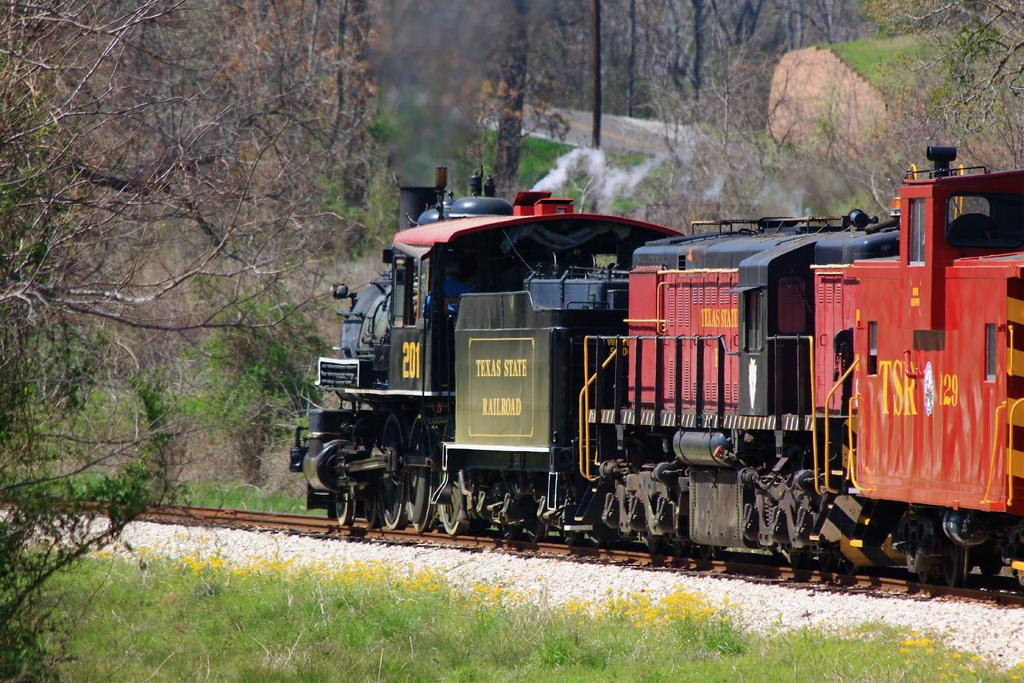What is the main subject of the image? The main subject of the image is a train. Where is the train located in the image? The train is on a track. What can be seen on either side of the train? There are trees on either side of the train. What type of sock is hanging from the train in the image? There is no sock hanging from the train in the image; it only features a train on a track with trees on either side. 